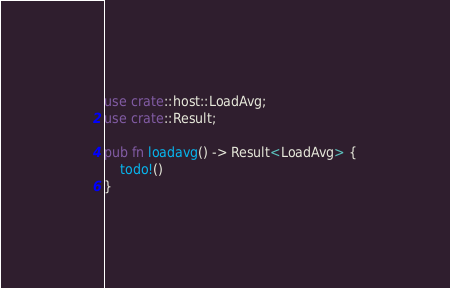Convert code to text. <code><loc_0><loc_0><loc_500><loc_500><_Rust_>use crate::host::LoadAvg;
use crate::Result;

pub fn loadavg() -> Result<LoadAvg> {
	todo!()
}
</code> 